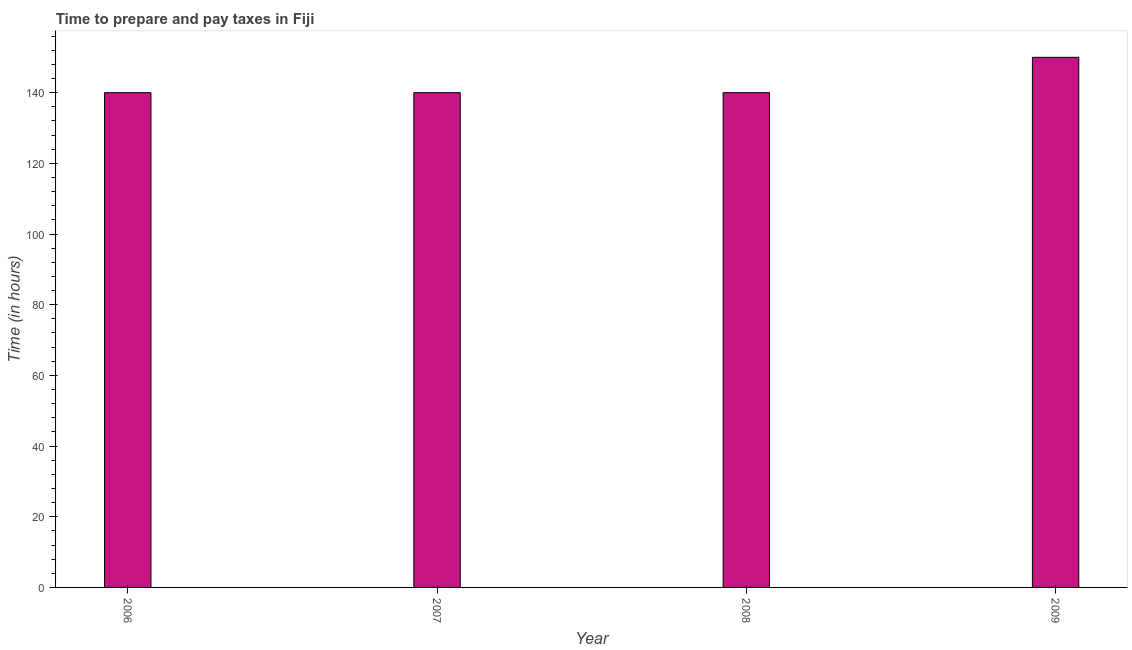Does the graph contain any zero values?
Your answer should be very brief. No. Does the graph contain grids?
Give a very brief answer. No. What is the title of the graph?
Ensure brevity in your answer.  Time to prepare and pay taxes in Fiji. What is the label or title of the Y-axis?
Provide a succinct answer. Time (in hours). What is the time to prepare and pay taxes in 2006?
Your response must be concise. 140. Across all years, what is the maximum time to prepare and pay taxes?
Ensure brevity in your answer.  150. Across all years, what is the minimum time to prepare and pay taxes?
Offer a very short reply. 140. In which year was the time to prepare and pay taxes maximum?
Give a very brief answer. 2009. What is the sum of the time to prepare and pay taxes?
Your answer should be very brief. 570. What is the difference between the time to prepare and pay taxes in 2006 and 2007?
Ensure brevity in your answer.  0. What is the average time to prepare and pay taxes per year?
Ensure brevity in your answer.  142. What is the median time to prepare and pay taxes?
Provide a short and direct response. 140. In how many years, is the time to prepare and pay taxes greater than 8 hours?
Your response must be concise. 4. Do a majority of the years between 2008 and 2009 (inclusive) have time to prepare and pay taxes greater than 100 hours?
Offer a terse response. Yes. What is the ratio of the time to prepare and pay taxes in 2008 to that in 2009?
Offer a very short reply. 0.93. Is the sum of the time to prepare and pay taxes in 2006 and 2007 greater than the maximum time to prepare and pay taxes across all years?
Keep it short and to the point. Yes. What is the difference between the highest and the lowest time to prepare and pay taxes?
Provide a short and direct response. 10. How many bars are there?
Your answer should be compact. 4. Are all the bars in the graph horizontal?
Provide a succinct answer. No. Are the values on the major ticks of Y-axis written in scientific E-notation?
Ensure brevity in your answer.  No. What is the Time (in hours) in 2006?
Provide a succinct answer. 140. What is the Time (in hours) of 2007?
Keep it short and to the point. 140. What is the Time (in hours) of 2008?
Provide a succinct answer. 140. What is the Time (in hours) in 2009?
Give a very brief answer. 150. What is the difference between the Time (in hours) in 2006 and 2007?
Offer a terse response. 0. What is the difference between the Time (in hours) in 2006 and 2008?
Provide a short and direct response. 0. What is the difference between the Time (in hours) in 2006 and 2009?
Ensure brevity in your answer.  -10. What is the ratio of the Time (in hours) in 2006 to that in 2007?
Offer a very short reply. 1. What is the ratio of the Time (in hours) in 2006 to that in 2009?
Give a very brief answer. 0.93. What is the ratio of the Time (in hours) in 2007 to that in 2009?
Ensure brevity in your answer.  0.93. What is the ratio of the Time (in hours) in 2008 to that in 2009?
Your answer should be compact. 0.93. 